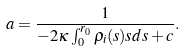Convert formula to latex. <formula><loc_0><loc_0><loc_500><loc_500>a = \frac { 1 } { - 2 \kappa \int _ { 0 } ^ { r _ { 0 } } { \rho _ { i } ( s ) s d s } + c } .</formula> 